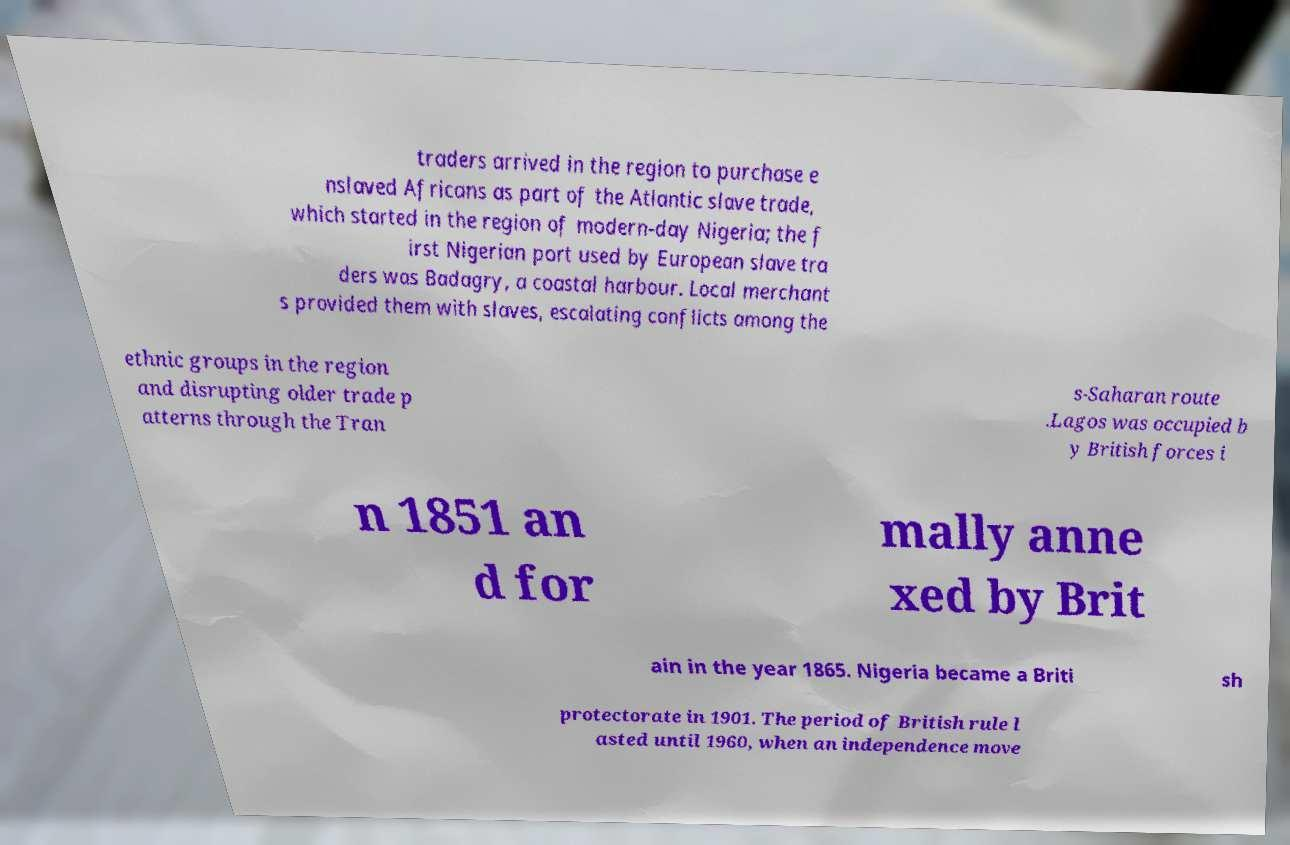I need the written content from this picture converted into text. Can you do that? traders arrived in the region to purchase e nslaved Africans as part of the Atlantic slave trade, which started in the region of modern-day Nigeria; the f irst Nigerian port used by European slave tra ders was Badagry, a coastal harbour. Local merchant s provided them with slaves, escalating conflicts among the ethnic groups in the region and disrupting older trade p atterns through the Tran s-Saharan route .Lagos was occupied b y British forces i n 1851 an d for mally anne xed by Brit ain in the year 1865. Nigeria became a Briti sh protectorate in 1901. The period of British rule l asted until 1960, when an independence move 